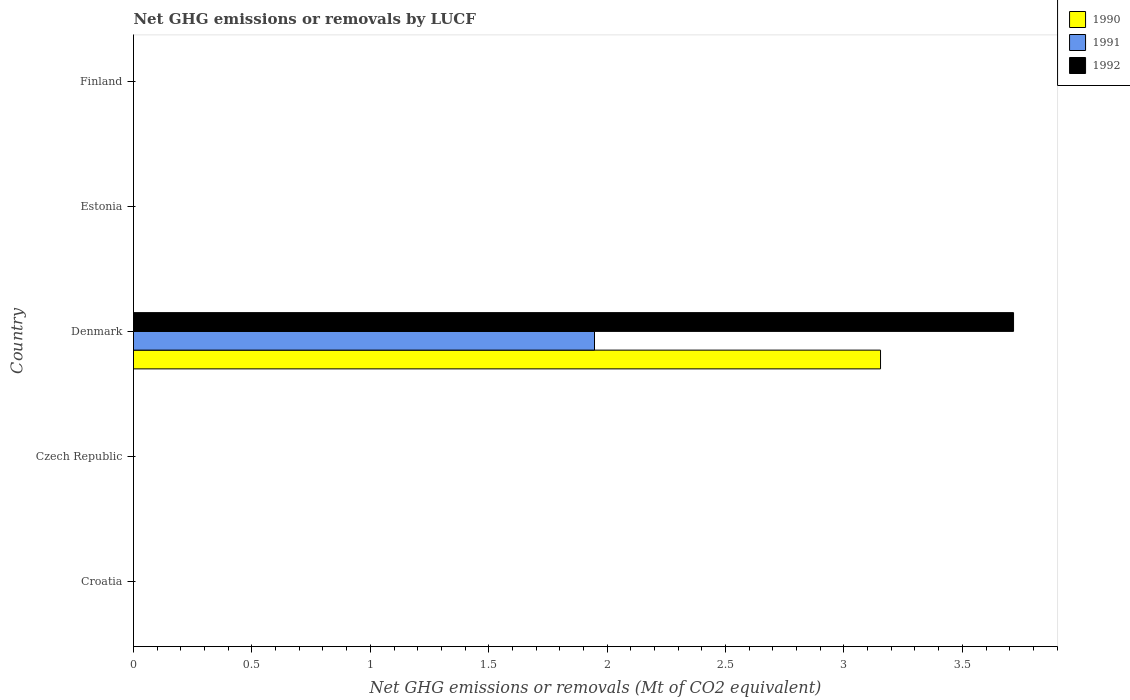How many different coloured bars are there?
Keep it short and to the point. 3. Are the number of bars on each tick of the Y-axis equal?
Your response must be concise. No. How many bars are there on the 5th tick from the top?
Provide a succinct answer. 0. What is the label of the 1st group of bars from the top?
Make the answer very short. Finland. In how many cases, is the number of bars for a given country not equal to the number of legend labels?
Your answer should be compact. 4. Across all countries, what is the maximum net GHG emissions or removals by LUCF in 1992?
Your answer should be very brief. 3.72. Across all countries, what is the minimum net GHG emissions or removals by LUCF in 1990?
Provide a short and direct response. 0. What is the total net GHG emissions or removals by LUCF in 1990 in the graph?
Provide a succinct answer. 3.15. What is the average net GHG emissions or removals by LUCF in 1990 per country?
Ensure brevity in your answer.  0.63. What is the difference between the net GHG emissions or removals by LUCF in 1991 and net GHG emissions or removals by LUCF in 1992 in Denmark?
Provide a short and direct response. -1.77. In how many countries, is the net GHG emissions or removals by LUCF in 1991 greater than 3.7 Mt?
Offer a terse response. 0. What is the difference between the highest and the lowest net GHG emissions or removals by LUCF in 1991?
Offer a very short reply. 1.95. In how many countries, is the net GHG emissions or removals by LUCF in 1992 greater than the average net GHG emissions or removals by LUCF in 1992 taken over all countries?
Offer a terse response. 1. Are all the bars in the graph horizontal?
Ensure brevity in your answer.  Yes. How many countries are there in the graph?
Provide a succinct answer. 5. What is the difference between two consecutive major ticks on the X-axis?
Keep it short and to the point. 0.5. Does the graph contain grids?
Give a very brief answer. No. Where does the legend appear in the graph?
Ensure brevity in your answer.  Top right. How many legend labels are there?
Ensure brevity in your answer.  3. How are the legend labels stacked?
Offer a very short reply. Vertical. What is the title of the graph?
Your answer should be very brief. Net GHG emissions or removals by LUCF. Does "2013" appear as one of the legend labels in the graph?
Your response must be concise. No. What is the label or title of the X-axis?
Provide a short and direct response. Net GHG emissions or removals (Mt of CO2 equivalent). What is the Net GHG emissions or removals (Mt of CO2 equivalent) of 1990 in Croatia?
Keep it short and to the point. 0. What is the Net GHG emissions or removals (Mt of CO2 equivalent) in 1992 in Croatia?
Ensure brevity in your answer.  0. What is the Net GHG emissions or removals (Mt of CO2 equivalent) of 1990 in Denmark?
Provide a short and direct response. 3.15. What is the Net GHG emissions or removals (Mt of CO2 equivalent) in 1991 in Denmark?
Your response must be concise. 1.95. What is the Net GHG emissions or removals (Mt of CO2 equivalent) of 1992 in Denmark?
Give a very brief answer. 3.72. What is the Net GHG emissions or removals (Mt of CO2 equivalent) of 1990 in Estonia?
Keep it short and to the point. 0. What is the Net GHG emissions or removals (Mt of CO2 equivalent) of 1992 in Estonia?
Give a very brief answer. 0. What is the Net GHG emissions or removals (Mt of CO2 equivalent) of 1990 in Finland?
Your response must be concise. 0. What is the Net GHG emissions or removals (Mt of CO2 equivalent) of 1991 in Finland?
Offer a terse response. 0. Across all countries, what is the maximum Net GHG emissions or removals (Mt of CO2 equivalent) of 1990?
Provide a succinct answer. 3.15. Across all countries, what is the maximum Net GHG emissions or removals (Mt of CO2 equivalent) in 1991?
Offer a very short reply. 1.95. Across all countries, what is the maximum Net GHG emissions or removals (Mt of CO2 equivalent) in 1992?
Your answer should be compact. 3.72. Across all countries, what is the minimum Net GHG emissions or removals (Mt of CO2 equivalent) in 1990?
Your answer should be very brief. 0. Across all countries, what is the minimum Net GHG emissions or removals (Mt of CO2 equivalent) in 1992?
Keep it short and to the point. 0. What is the total Net GHG emissions or removals (Mt of CO2 equivalent) in 1990 in the graph?
Make the answer very short. 3.15. What is the total Net GHG emissions or removals (Mt of CO2 equivalent) in 1991 in the graph?
Provide a succinct answer. 1.95. What is the total Net GHG emissions or removals (Mt of CO2 equivalent) in 1992 in the graph?
Your response must be concise. 3.72. What is the average Net GHG emissions or removals (Mt of CO2 equivalent) of 1990 per country?
Make the answer very short. 0.63. What is the average Net GHG emissions or removals (Mt of CO2 equivalent) in 1991 per country?
Make the answer very short. 0.39. What is the average Net GHG emissions or removals (Mt of CO2 equivalent) in 1992 per country?
Your response must be concise. 0.74. What is the difference between the Net GHG emissions or removals (Mt of CO2 equivalent) of 1990 and Net GHG emissions or removals (Mt of CO2 equivalent) of 1991 in Denmark?
Your answer should be very brief. 1.21. What is the difference between the Net GHG emissions or removals (Mt of CO2 equivalent) of 1990 and Net GHG emissions or removals (Mt of CO2 equivalent) of 1992 in Denmark?
Provide a short and direct response. -0.56. What is the difference between the Net GHG emissions or removals (Mt of CO2 equivalent) in 1991 and Net GHG emissions or removals (Mt of CO2 equivalent) in 1992 in Denmark?
Your answer should be very brief. -1.77. What is the difference between the highest and the lowest Net GHG emissions or removals (Mt of CO2 equivalent) in 1990?
Give a very brief answer. 3.15. What is the difference between the highest and the lowest Net GHG emissions or removals (Mt of CO2 equivalent) in 1991?
Your response must be concise. 1.95. What is the difference between the highest and the lowest Net GHG emissions or removals (Mt of CO2 equivalent) of 1992?
Offer a very short reply. 3.72. 